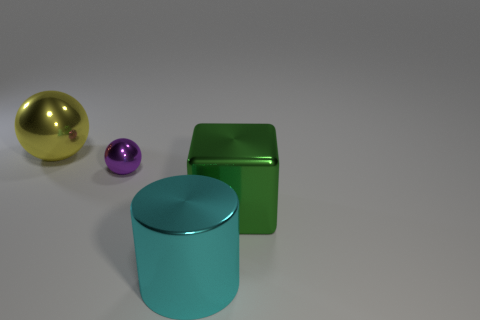Are there any other things that are the same size as the purple metallic sphere?
Your answer should be very brief. No. The large object that is the same shape as the small purple metallic object is what color?
Offer a very short reply. Yellow. What number of other objects are the same color as the block?
Ensure brevity in your answer.  0. There is a big thing behind the purple shiny thing; is it the same shape as the tiny thing that is on the left side of the green block?
Your response must be concise. Yes. What number of cylinders are either big yellow things or purple metallic things?
Give a very brief answer. 0. Are there fewer big yellow objects that are to the right of the purple metal ball than big cyan metal objects?
Make the answer very short. Yes. How many other things are there of the same material as the purple object?
Make the answer very short. 3. Do the purple object and the green shiny block have the same size?
Ensure brevity in your answer.  No. What number of objects are either tiny things behind the large green object or large green metal cubes?
Ensure brevity in your answer.  2. What is the object behind the sphere in front of the yellow metallic ball made of?
Give a very brief answer. Metal. 